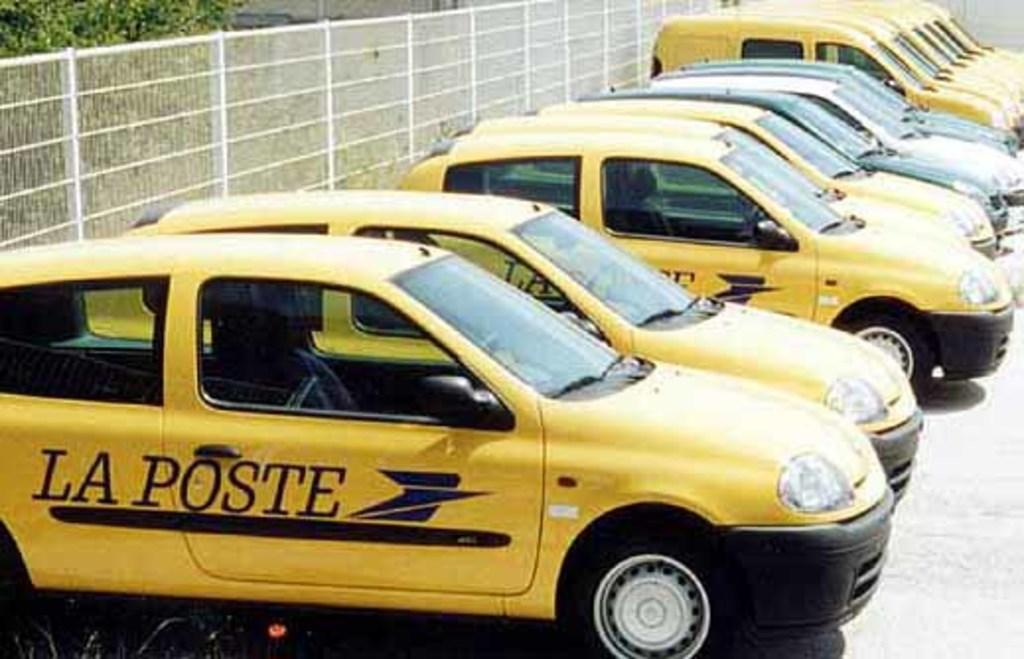<image>
Present a compact description of the photo's key features. Yellow La Poste taxi cabs parked next to one another. 